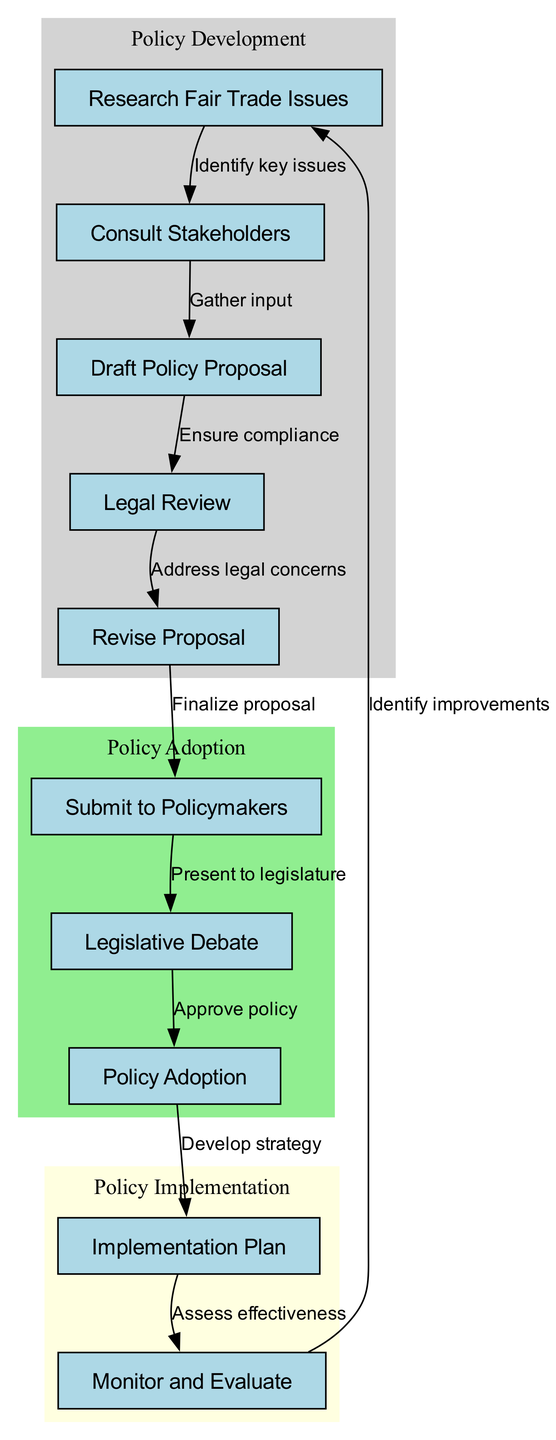What is the first step in the policy process? The first step in the flowchart is "Research Fair Trade Issues," which is indicated as node 1 in the diagram.
Answer: Research Fair Trade Issues How many nodes are in the diagram? The diagram contains a total of 10 nodes, as listed in the data provided for the fair trade policy process.
Answer: 10 Which nodes are grouped under "Policy Development"? The nodes under the "Policy Development" cluster include nodes 1, 2, 3, 4, and 5, as specified in the diagram's subgraph attribute.
Answer: Research Fair Trade Issues, Consult Stakeholders, Draft Policy Proposal, Legal Review, Revise Proposal What comes after "Submit to Policymakers"? The step that follows "Submit to Policymakers," which is node 6, is "Legislative Debate," indicated as node 7 in the flowchart.
Answer: Legislative Debate Which node involves assessing the effectiveness of the policy? The node dedicated to assessing the effectiveness of the policy is "Monitor and Evaluate," represented as node 10 in the diagram.
Answer: Monitor and Evaluate How many edges connect the "Policy Adoption" phase? There are three edges connecting the "Policy Adoption" phase, which includes nodes 6, 7, and 8. The edges are from "Submit to Policymakers" to "Legislative Debate," then to "Policy Adoption."
Answer: 3 What is the purpose of revising the policy proposal? The purpose of revising the policy proposal, represented by node 5, is to "Address legal concerns," which comes after the legal review in node 4 before submitting the finalized proposal.
Answer: Address legal concerns Which phase includes monitoring and evaluating the policy after implementation? The phase that includes monitoring and evaluating the policy after implementation is "Policy Implementation," which contains node 9 and node 10 in the diagram flow.
Answer: Policy Implementation 